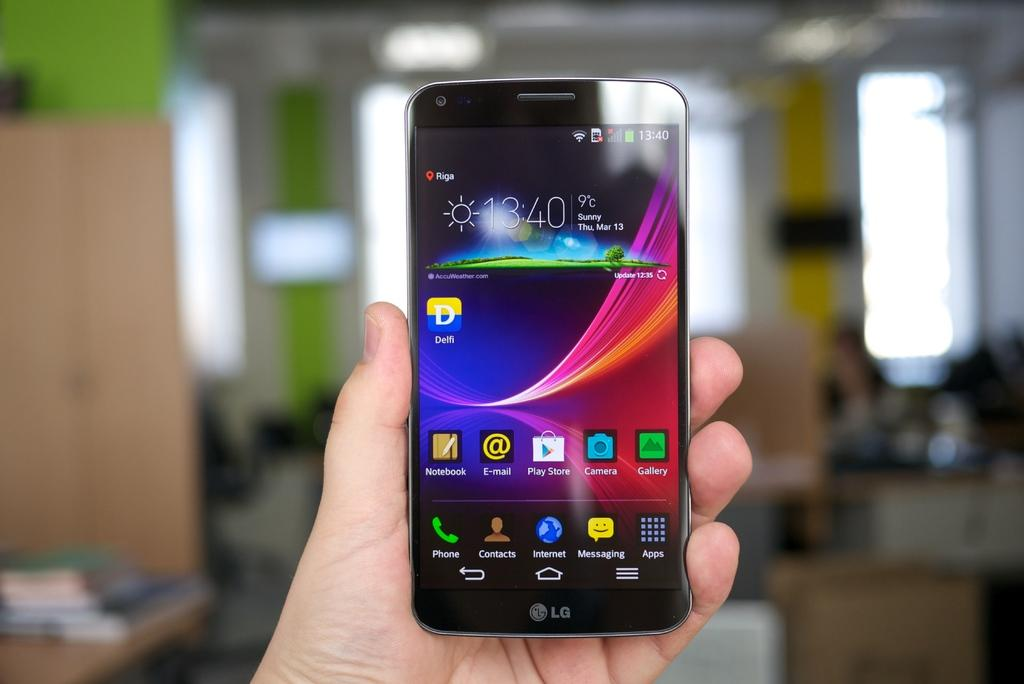<image>
Offer a succinct explanation of the picture presented. A person holds a LG phone that is turned on to the home screen that shows the time as 13:40. 